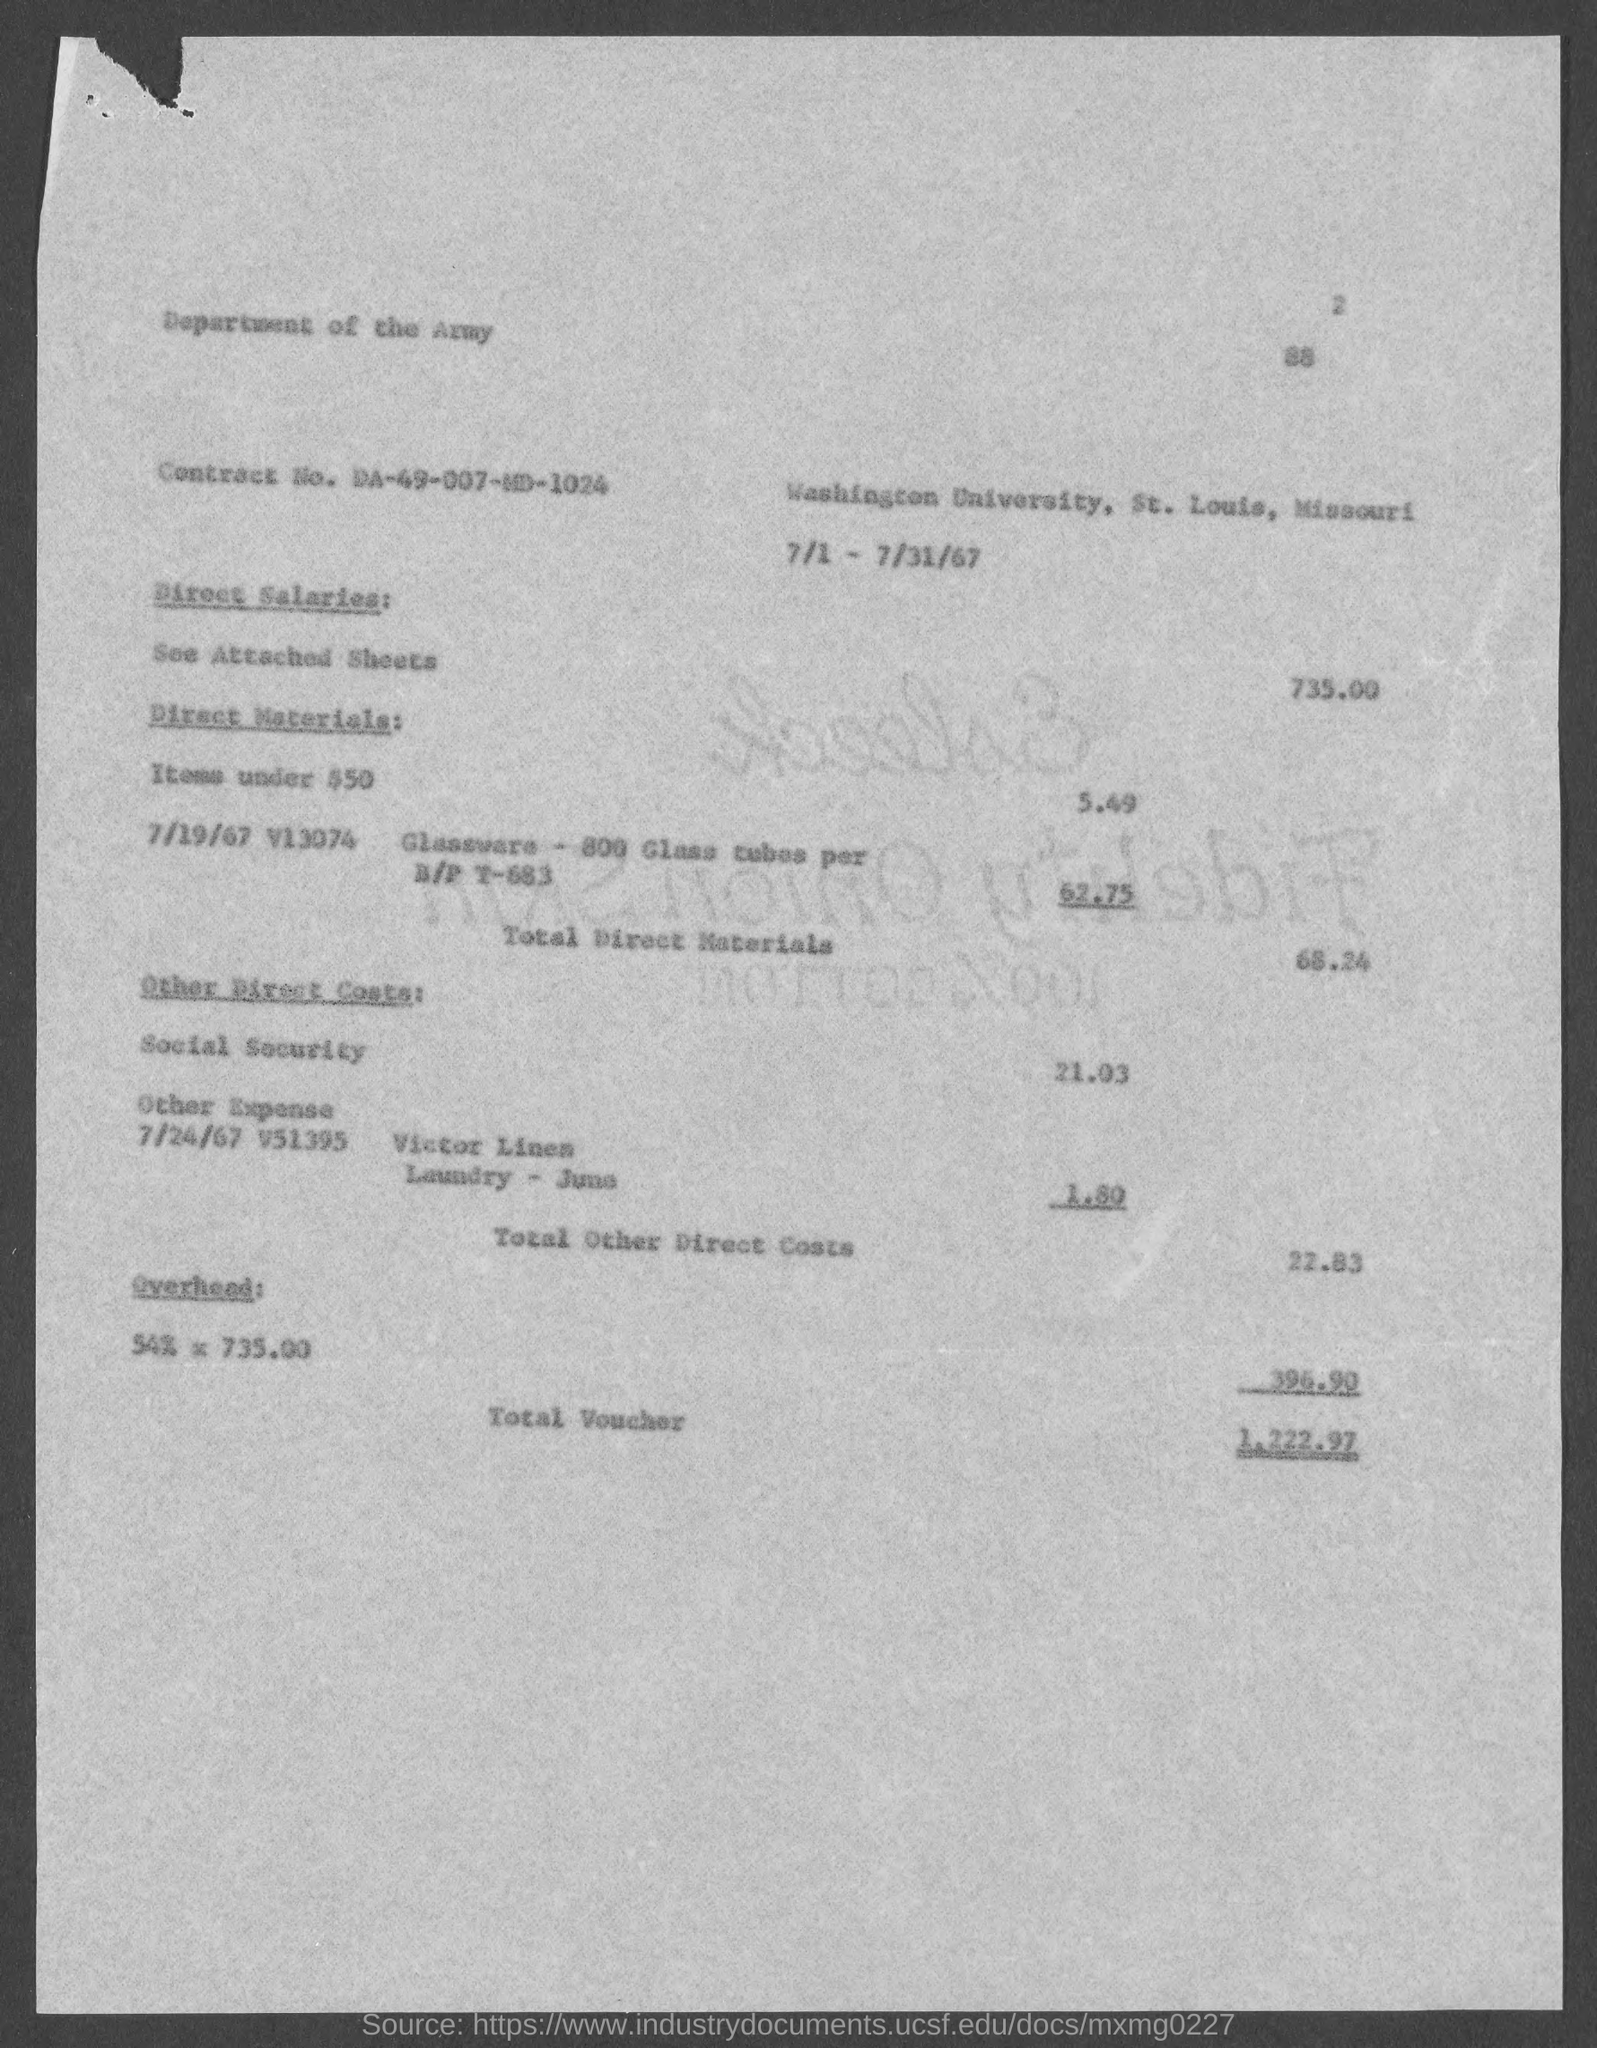What is the Contract No. given in the document?
Ensure brevity in your answer.  DA-49-007-MD-1024. What is the direct salaries cost mentioned in the document?
Your answer should be compact. 735.00. What is the total voucher amount mentioned in the document?
Make the answer very short. 1,222.97. 